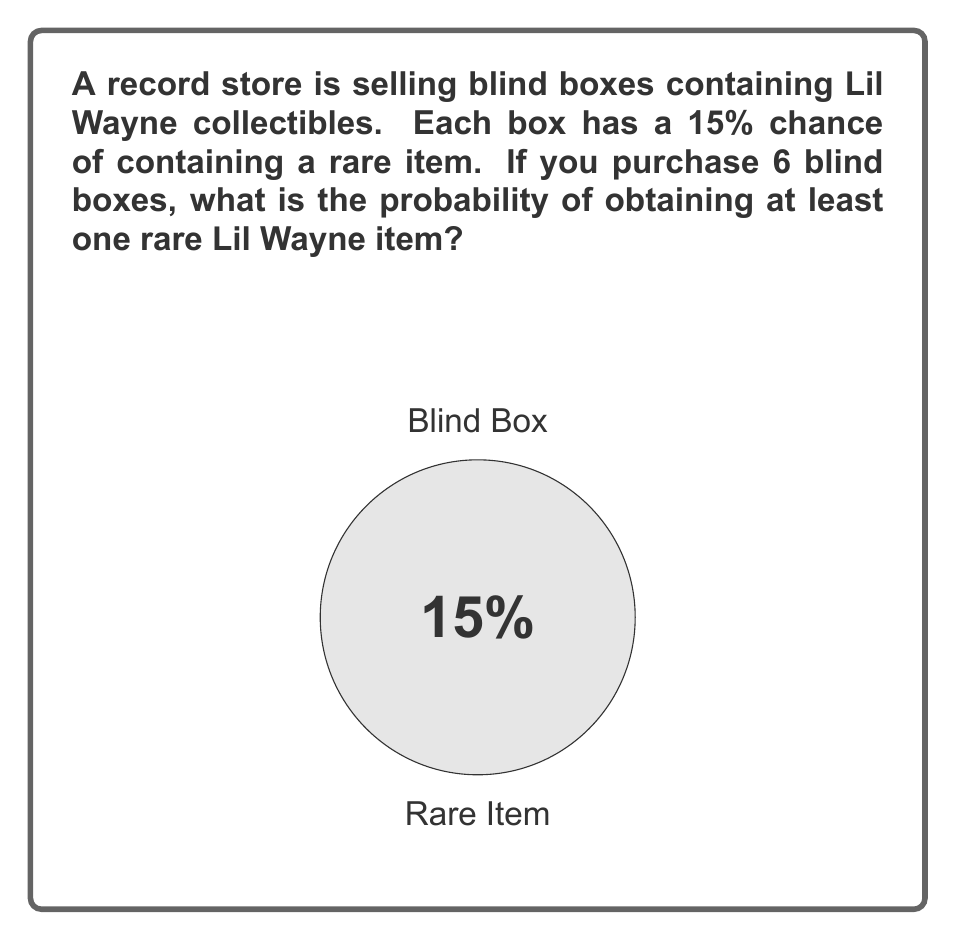Can you solve this math problem? Let's approach this step-by-step:

1) First, let's calculate the probability of not getting a rare item in a single box:
   $P(\text{not rare}) = 1 - 0.15 = 0.85$ or 85%

2) Now, for all 6 boxes to not contain a rare item, this needs to happen 6 times in a row:
   $P(\text{no rare items in 6 boxes}) = 0.85^6$

3) Let's calculate this:
   $0.85^6 \approx 0.3771$ or about 37.71%

4) This is the probability of getting no rare items. We want the probability of getting at least one rare item, which is the opposite event:
   $P(\text{at least one rare item}) = 1 - P(\text{no rare items})$

5) Therefore:
   $P(\text{at least one rare item}) = 1 - 0.3771 = 0.6229$

6) Converting to a percentage:
   $0.6229 \times 100\% = 62.29\%$

Thus, the probability of obtaining at least one rare Lil Wayne item when purchasing 6 blind boxes is approximately 62.29%.
Answer: $62.29\%$ 